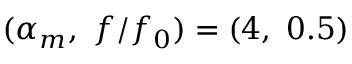<formula> <loc_0><loc_0><loc_500><loc_500>( \alpha _ { m } , \ f / f _ { 0 } ) = ( 4 , \ 0 . 5 )</formula> 